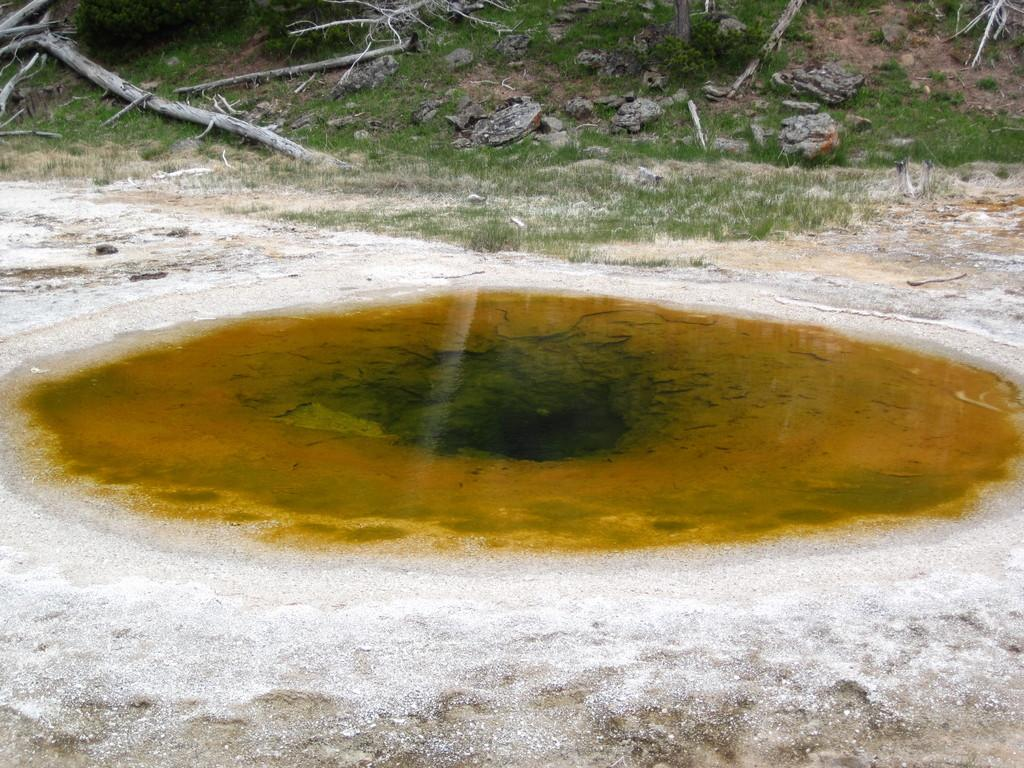What type of terrain is depicted in the image? The image contains sand and water, suggesting a beach or shoreline. What can be found at the top of the image? There are stones, grass, and stems at the top of the image. Can you describe the vegetation present in the image? The vegetation in the image includes stems, which may be part of plants or flowers. How does the image adjust the brightness of the sun? The image does not have the ability to adjust the brightness of the sun, as it is a static representation. 